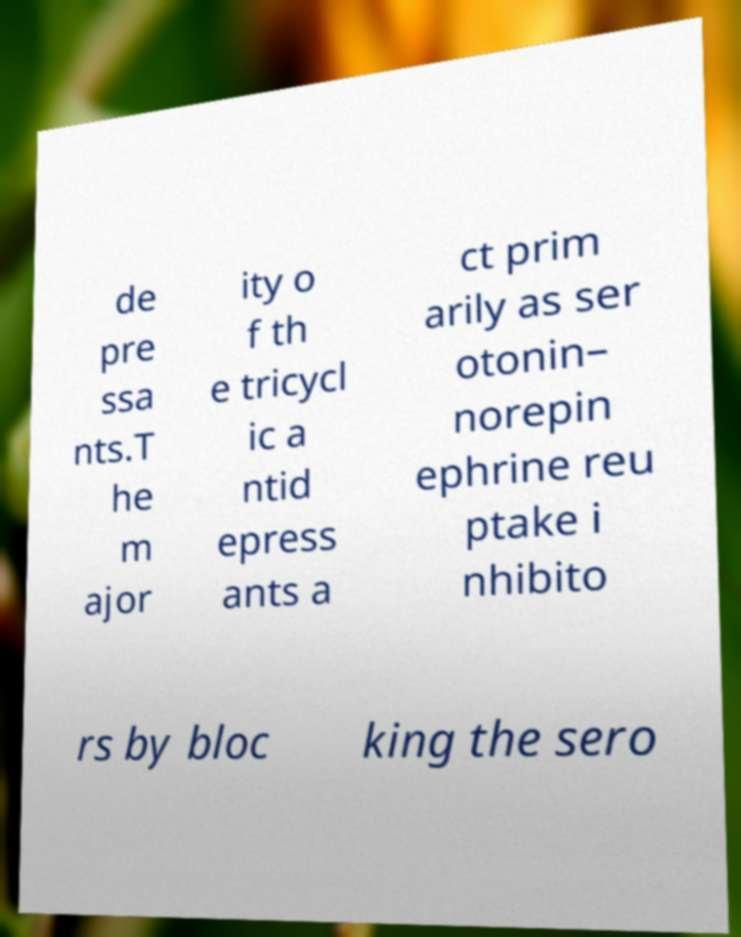For documentation purposes, I need the text within this image transcribed. Could you provide that? de pre ssa nts.T he m ajor ity o f th e tricycl ic a ntid epress ants a ct prim arily as ser otonin– norepin ephrine reu ptake i nhibito rs by bloc king the sero 